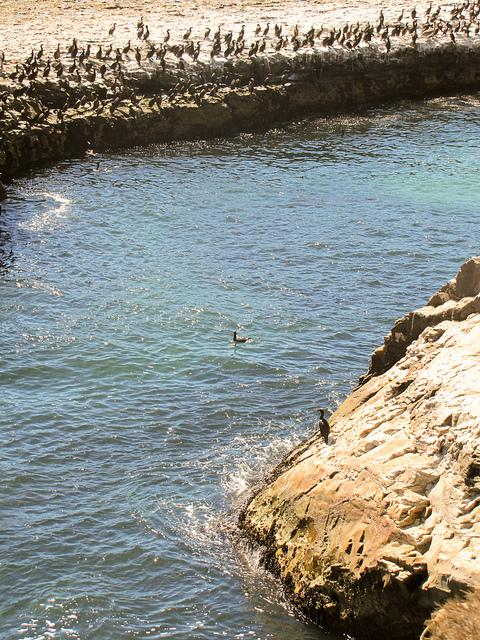What is usually found inside of the large blue item? fish 